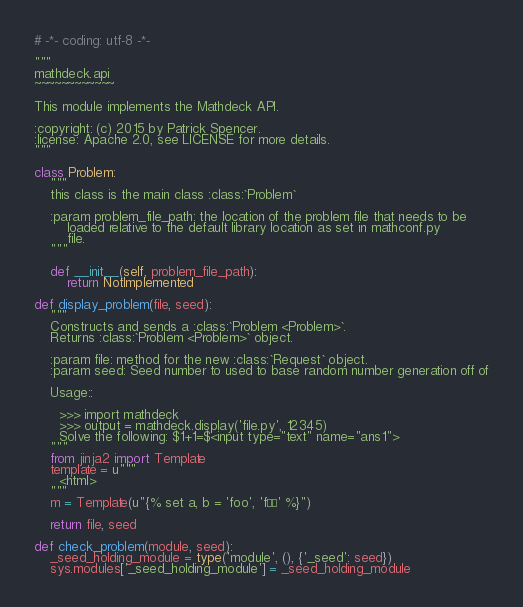<code> <loc_0><loc_0><loc_500><loc_500><_Python_># -*- coding: utf-8 -*-

"""
mathdeck.api
~~~~~~~~~~~~

This module implements the Mathdeck API.

:copyright: (c) 2015 by Patrick Spencer.
:license: Apache 2.0, see LICENSE for more details.
"""

class Problem:
    """
    this class is the main class :class:`Problem`
    
    :param problem_file_path: the location of the problem file that needs to be
        loaded relative to the default library location as set in mathconf.py
        file.
    """

    def __init__(self, problem_file_path):
        return NotImplemented

def display_problem(file, seed):
    """
    Constructs and sends a :class:`Problem <Problem>`.
    Returns :class:`Problem <Problem>` object.

    :param file: method for the new :class:`Request` object.
    :param seed: Seed number to used to base random number generation off of

    Usage::

      >>> import mathdeck
      >>> output = mathdeck.display('file.py', 12345)
      Solve the following: $1+1=$<input type="text" name="ans1">
    """
    from jinja2 import Template
    template = u"""
      <html>
    """
    m = Template(u"{% set a, b = 'foo', 'föö' %}")

    return file, seed

def check_problem(module, seed):
    _seed_holding_module = type('module', (), {'_seed': seed})
    sys.modules['_seed_holding_module'] = _seed_holding_module
</code> 